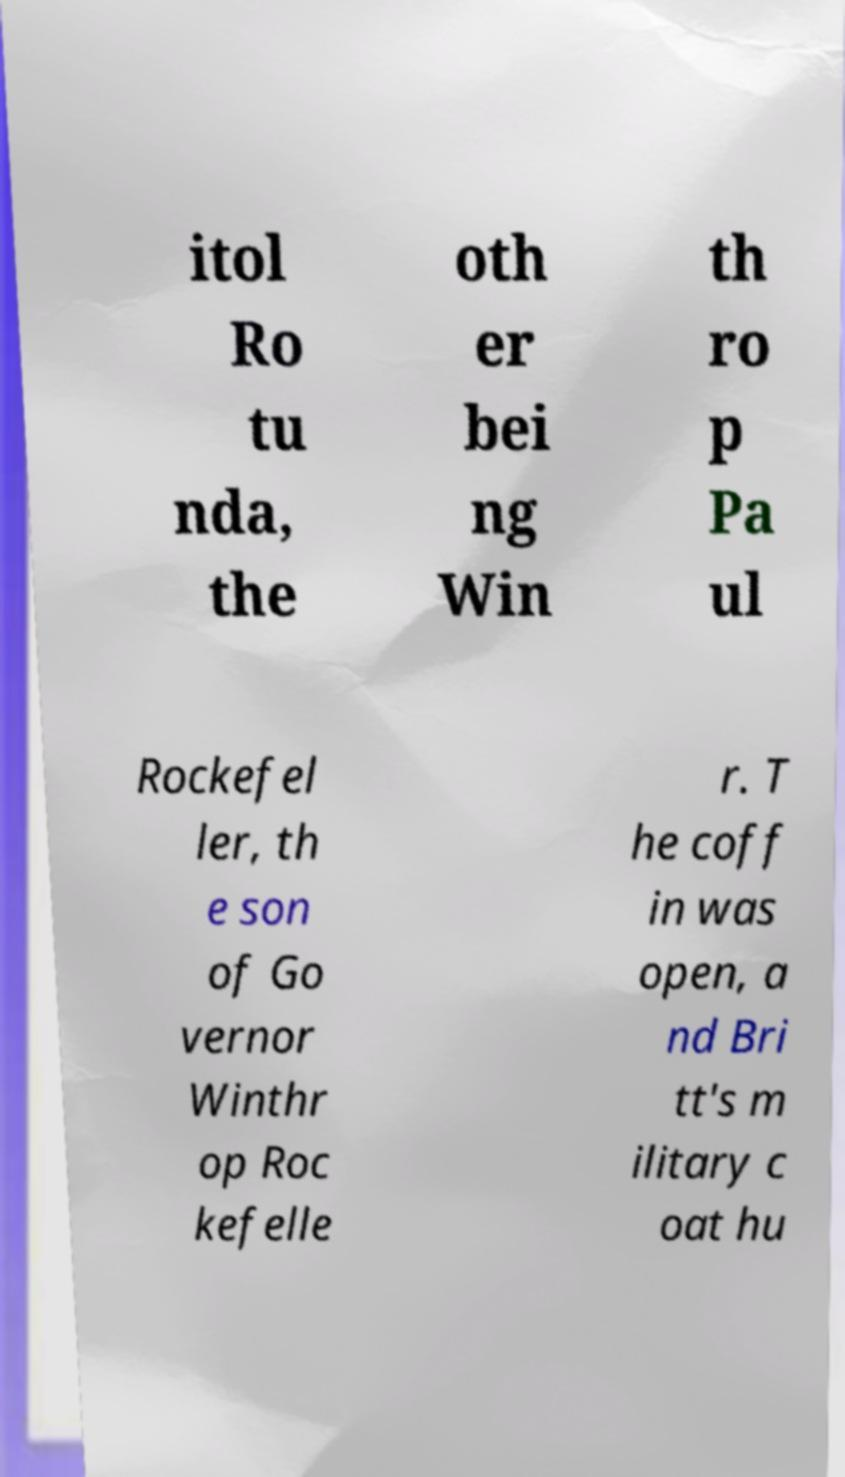I need the written content from this picture converted into text. Can you do that? itol Ro tu nda, the oth er bei ng Win th ro p Pa ul Rockefel ler, th e son of Go vernor Winthr op Roc kefelle r. T he coff in was open, a nd Bri tt's m ilitary c oat hu 